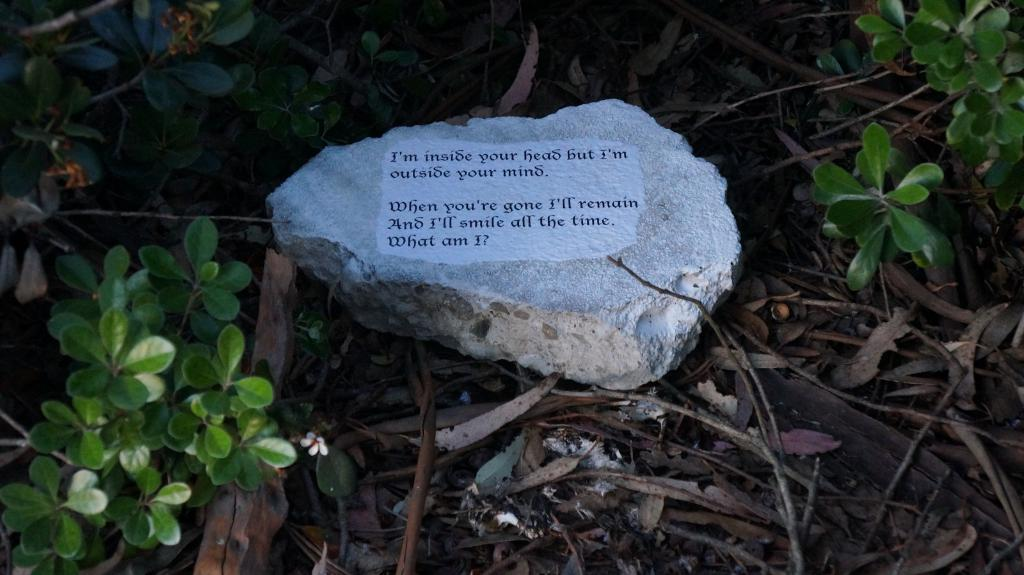What is the main subject of the image? The main subject of the image is a rock with text. Where is the rock located in the image? The rock is placed on the ground. What else can be seen in the image besides the rock? There are plants around the rock. What type of skin can be seen on the rock in the image? There is no skin present on the rock in the image; it is a rock with text. 